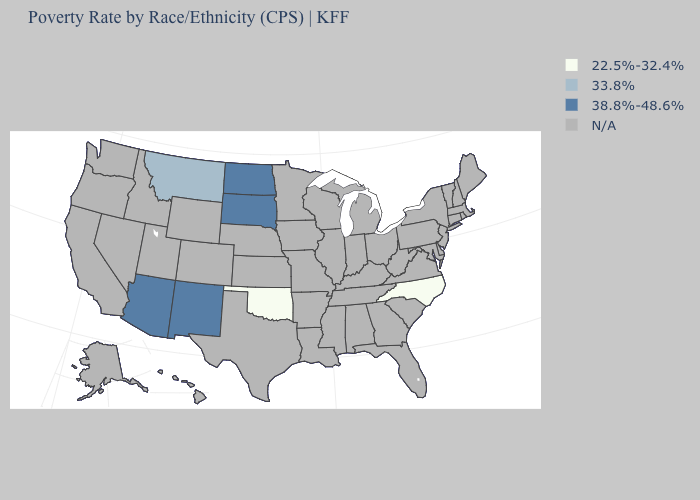Name the states that have a value in the range 33.8%?
Answer briefly. Montana. What is the value of Mississippi?
Quick response, please. N/A. Name the states that have a value in the range 33.8%?
Answer briefly. Montana. Which states have the lowest value in the West?
Keep it brief. Montana. What is the value of Minnesota?
Answer briefly. N/A. What is the value of Utah?
Concise answer only. N/A. What is the value of New York?
Concise answer only. N/A. Is the legend a continuous bar?
Answer briefly. No. What is the lowest value in the USA?
Answer briefly. 22.5%-32.4%. What is the value of Vermont?
Quick response, please. N/A. Is the legend a continuous bar?
Be succinct. No. Name the states that have a value in the range 38.8%-48.6%?
Answer briefly. Arizona, New Mexico, North Dakota, South Dakota. 